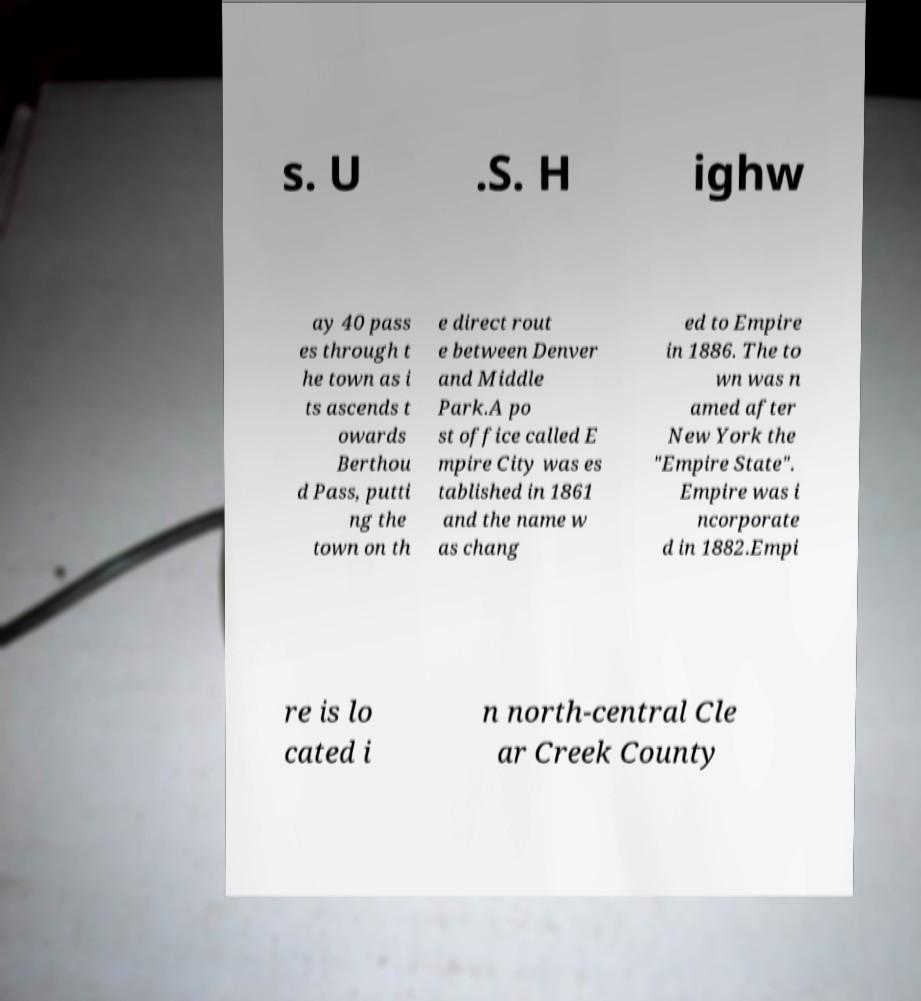Can you accurately transcribe the text from the provided image for me? s. U .S. H ighw ay 40 pass es through t he town as i ts ascends t owards Berthou d Pass, putti ng the town on th e direct rout e between Denver and Middle Park.A po st office called E mpire City was es tablished in 1861 and the name w as chang ed to Empire in 1886. The to wn was n amed after New York the "Empire State". Empire was i ncorporate d in 1882.Empi re is lo cated i n north-central Cle ar Creek County 